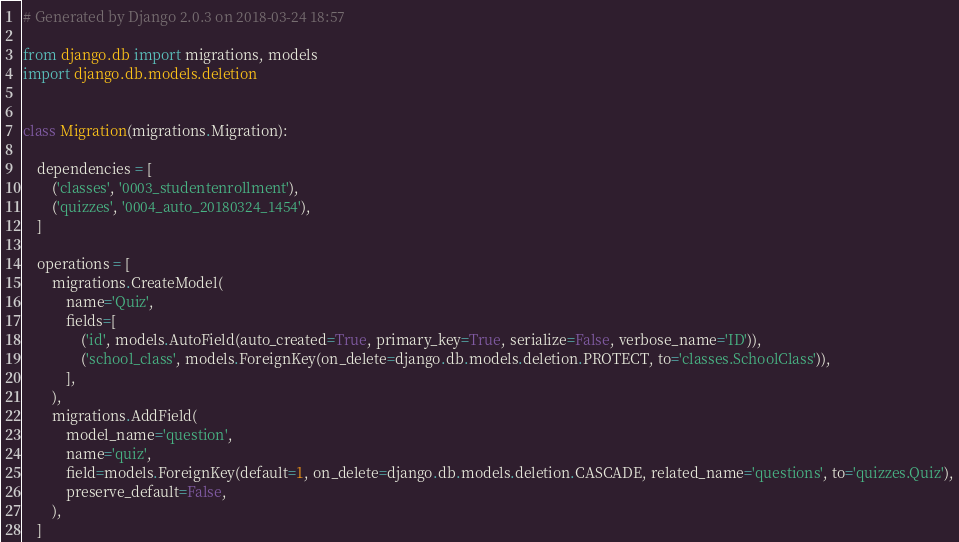Convert code to text. <code><loc_0><loc_0><loc_500><loc_500><_Python_># Generated by Django 2.0.3 on 2018-03-24 18:57

from django.db import migrations, models
import django.db.models.deletion


class Migration(migrations.Migration):

    dependencies = [
        ('classes', '0003_studentenrollment'),
        ('quizzes', '0004_auto_20180324_1454'),
    ]

    operations = [
        migrations.CreateModel(
            name='Quiz',
            fields=[
                ('id', models.AutoField(auto_created=True, primary_key=True, serialize=False, verbose_name='ID')),
                ('school_class', models.ForeignKey(on_delete=django.db.models.deletion.PROTECT, to='classes.SchoolClass')),
            ],
        ),
        migrations.AddField(
            model_name='question',
            name='quiz',
            field=models.ForeignKey(default=1, on_delete=django.db.models.deletion.CASCADE, related_name='questions', to='quizzes.Quiz'),
            preserve_default=False,
        ),
    ]
</code> 